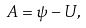Convert formula to latex. <formula><loc_0><loc_0><loc_500><loc_500>A = \psi - U ,</formula> 